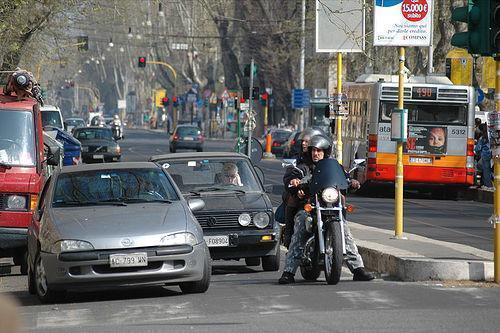Why are all the vehicles on the left not moving?
Select the correct answer and articulate reasoning with the following format: 'Answer: answer
Rationale: rationale.'
Options: Tired, red light, parade, accident. Answer: red light.
Rationale: The vehicles are at a red light. 